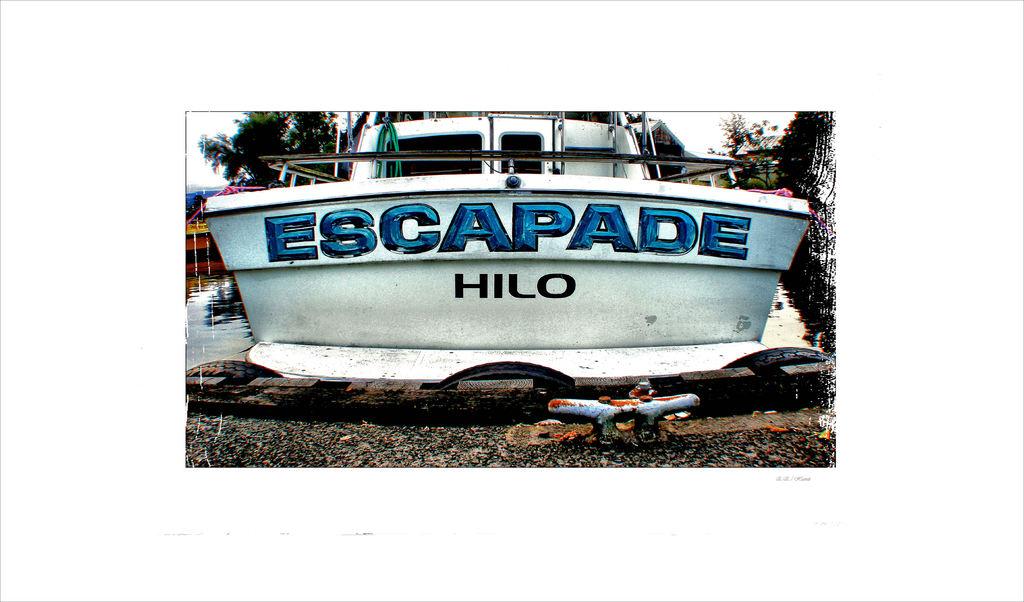What is the name of the boat?
Keep it short and to the point. Escapade. 